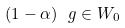Convert formula to latex. <formula><loc_0><loc_0><loc_500><loc_500>( 1 - \alpha ) \ g \in W _ { 0 }</formula> 